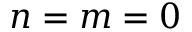Convert formula to latex. <formula><loc_0><loc_0><loc_500><loc_500>n = m = 0</formula> 